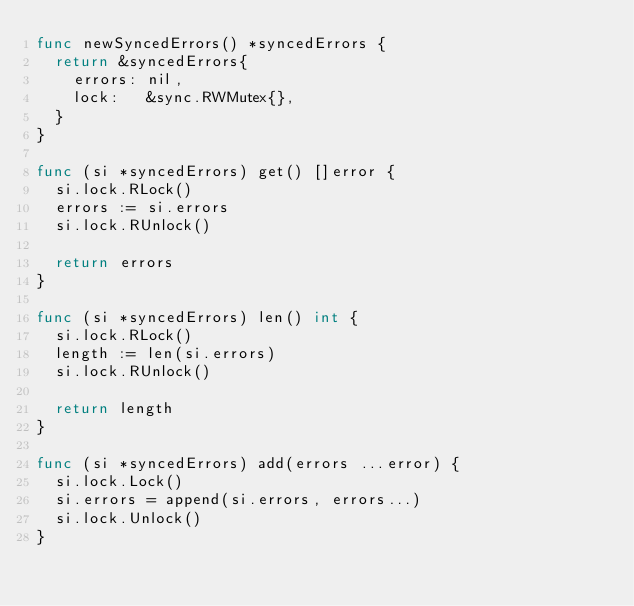Convert code to text. <code><loc_0><loc_0><loc_500><loc_500><_Go_>func newSyncedErrors() *syncedErrors {
	return &syncedErrors{
		errors: nil,
		lock:   &sync.RWMutex{},
	}
}

func (si *syncedErrors) get() []error {
	si.lock.RLock()
	errors := si.errors
	si.lock.RUnlock()

	return errors
}

func (si *syncedErrors) len() int {
	si.lock.RLock()
	length := len(si.errors)
	si.lock.RUnlock()

	return length
}

func (si *syncedErrors) add(errors ...error) {
	si.lock.Lock()
	si.errors = append(si.errors, errors...)
	si.lock.Unlock()
}
</code> 